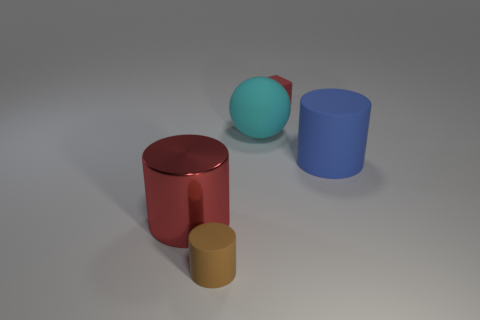Is there anything else that has the same material as the big red cylinder?
Offer a very short reply. No. There is a cylinder behind the red metal cylinder; is its size the same as the rubber cylinder that is left of the cyan rubber sphere?
Offer a very short reply. No. What material is the red object that is the same shape as the big blue thing?
Offer a very short reply. Metal. What number of large things are blue objects or blue shiny objects?
Give a very brief answer. 1. What material is the tiny red cube?
Keep it short and to the point. Rubber. The thing that is both right of the large red thing and to the left of the large matte sphere is made of what material?
Your response must be concise. Rubber. There is a small cylinder; is it the same color as the tiny thing behind the big red metallic cylinder?
Offer a terse response. No. There is a red thing that is the same size as the matte sphere; what is its material?
Keep it short and to the point. Metal. Are there any tiny red blocks that have the same material as the large blue cylinder?
Your response must be concise. Yes. How many large yellow metal objects are there?
Make the answer very short. 0. 